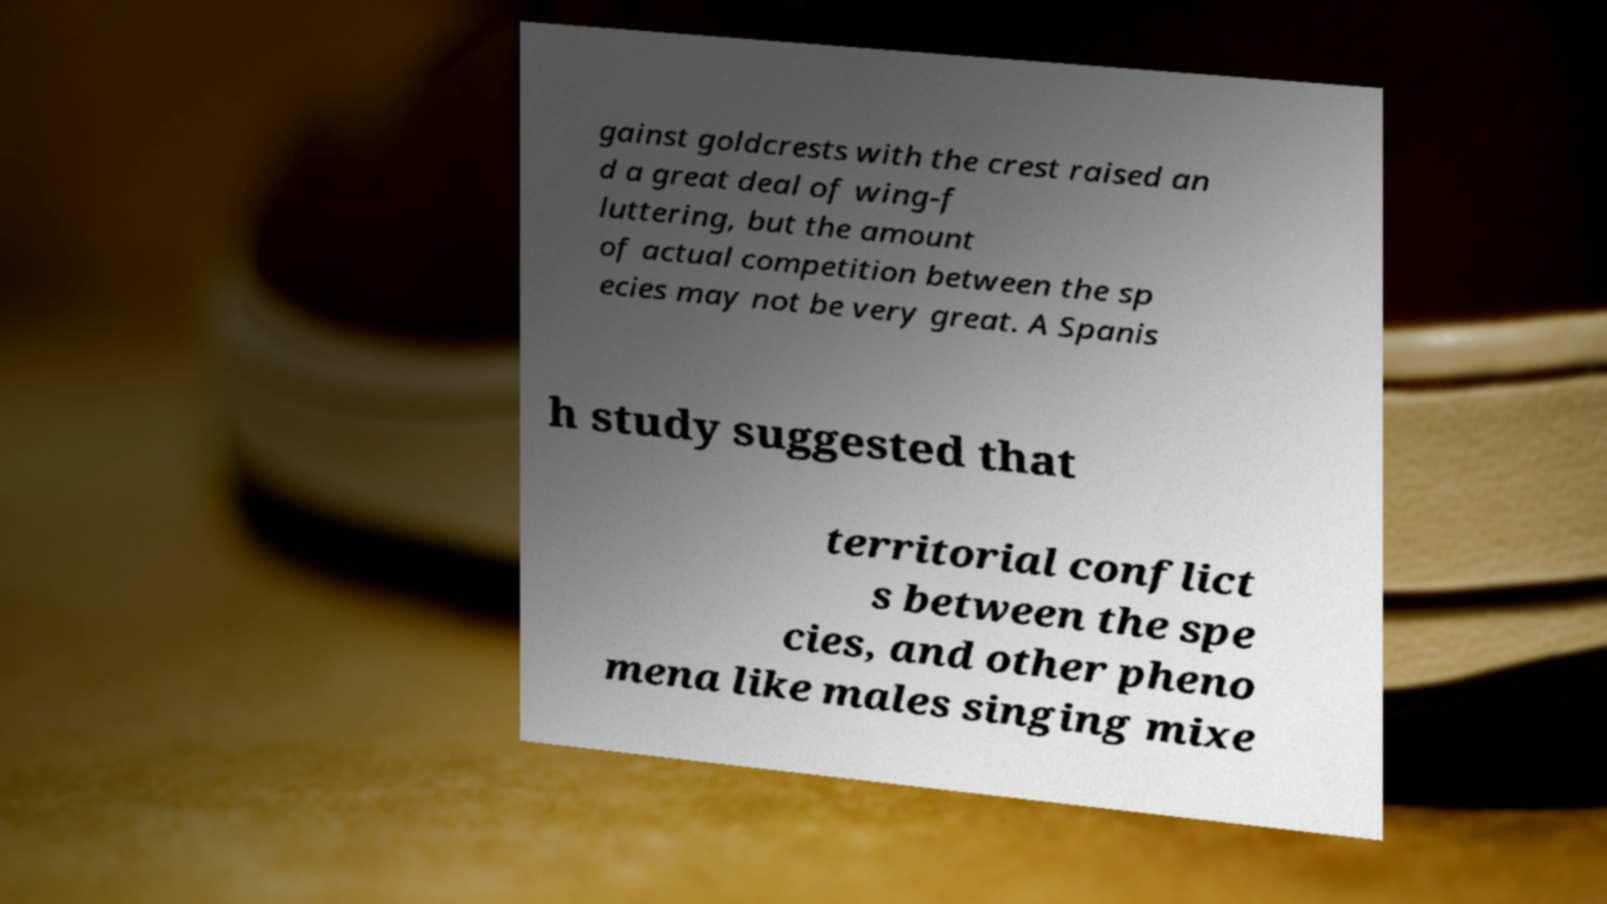There's text embedded in this image that I need extracted. Can you transcribe it verbatim? gainst goldcrests with the crest raised an d a great deal of wing-f luttering, but the amount of actual competition between the sp ecies may not be very great. A Spanis h study suggested that territorial conflict s between the spe cies, and other pheno mena like males singing mixe 